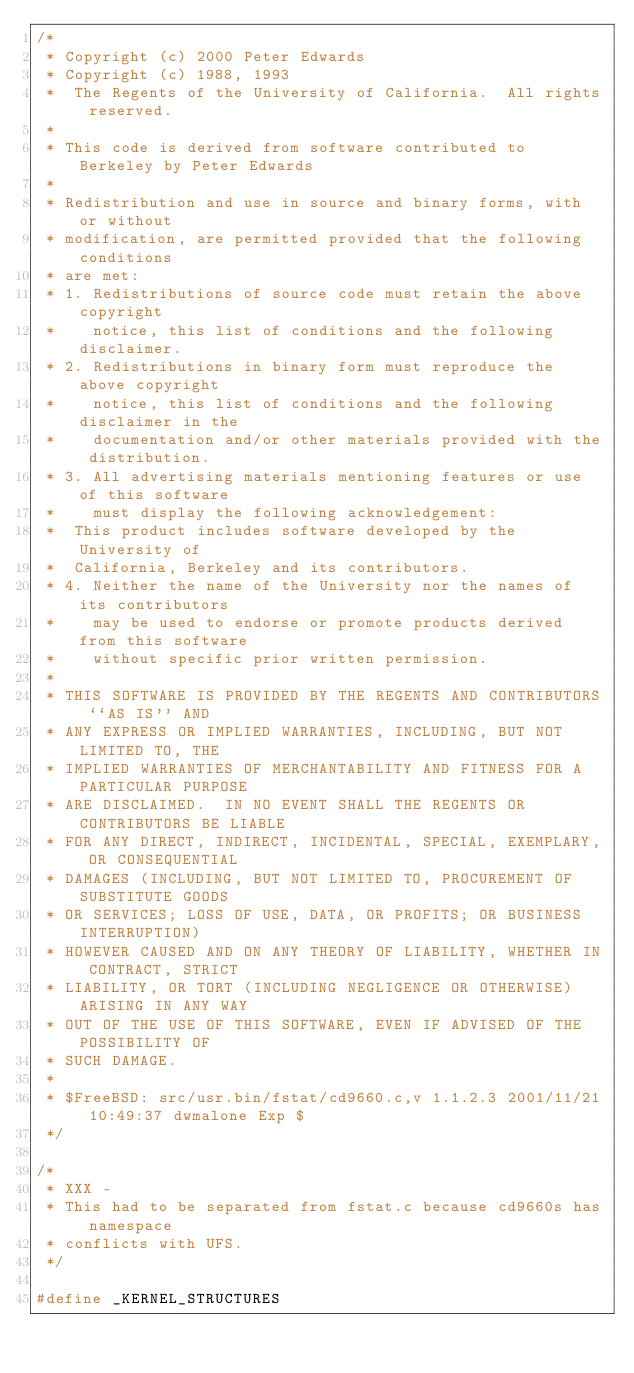<code> <loc_0><loc_0><loc_500><loc_500><_C_>/* 
 * Copyright (c) 2000 Peter Edwards
 * Copyright (c) 1988, 1993
 *	The Regents of the University of California.  All rights reserved.
 *
 * This code is derived from software contributed to Berkeley by Peter Edwards
 *
 * Redistribution and use in source and binary forms, with or without
 * modification, are permitted provided that the following conditions
 * are met:
 * 1. Redistributions of source code must retain the above copyright
 *    notice, this list of conditions and the following disclaimer.
 * 2. Redistributions in binary form must reproduce the above copyright
 *    notice, this list of conditions and the following disclaimer in the
 *    documentation and/or other materials provided with the distribution.
 * 3. All advertising materials mentioning features or use of this software
 *    must display the following acknowledgement:
 *	This product includes software developed by the University of
 *	California, Berkeley and its contributors.
 * 4. Neither the name of the University nor the names of its contributors
 *    may be used to endorse or promote products derived from this software
 *    without specific prior written permission.
 *
 * THIS SOFTWARE IS PROVIDED BY THE REGENTS AND CONTRIBUTORS ``AS IS'' AND
 * ANY EXPRESS OR IMPLIED WARRANTIES, INCLUDING, BUT NOT LIMITED TO, THE
 * IMPLIED WARRANTIES OF MERCHANTABILITY AND FITNESS FOR A PARTICULAR PURPOSE
 * ARE DISCLAIMED.  IN NO EVENT SHALL THE REGENTS OR CONTRIBUTORS BE LIABLE
 * FOR ANY DIRECT, INDIRECT, INCIDENTAL, SPECIAL, EXEMPLARY, OR CONSEQUENTIAL
 * DAMAGES (INCLUDING, BUT NOT LIMITED TO, PROCUREMENT OF SUBSTITUTE GOODS
 * OR SERVICES; LOSS OF USE, DATA, OR PROFITS; OR BUSINESS INTERRUPTION)
 * HOWEVER CAUSED AND ON ANY THEORY OF LIABILITY, WHETHER IN CONTRACT, STRICT
 * LIABILITY, OR TORT (INCLUDING NEGLIGENCE OR OTHERWISE) ARISING IN ANY WAY
 * OUT OF THE USE OF THIS SOFTWARE, EVEN IF ADVISED OF THE POSSIBILITY OF
 * SUCH DAMAGE.
 *
 * $FreeBSD: src/usr.bin/fstat/cd9660.c,v 1.1.2.3 2001/11/21 10:49:37 dwmalone Exp $
 */

/*
 * XXX -
 * This had to be separated from fstat.c because cd9660s has namespace
 * conflicts with UFS.
 */

#define _KERNEL_STRUCTURES
</code> 